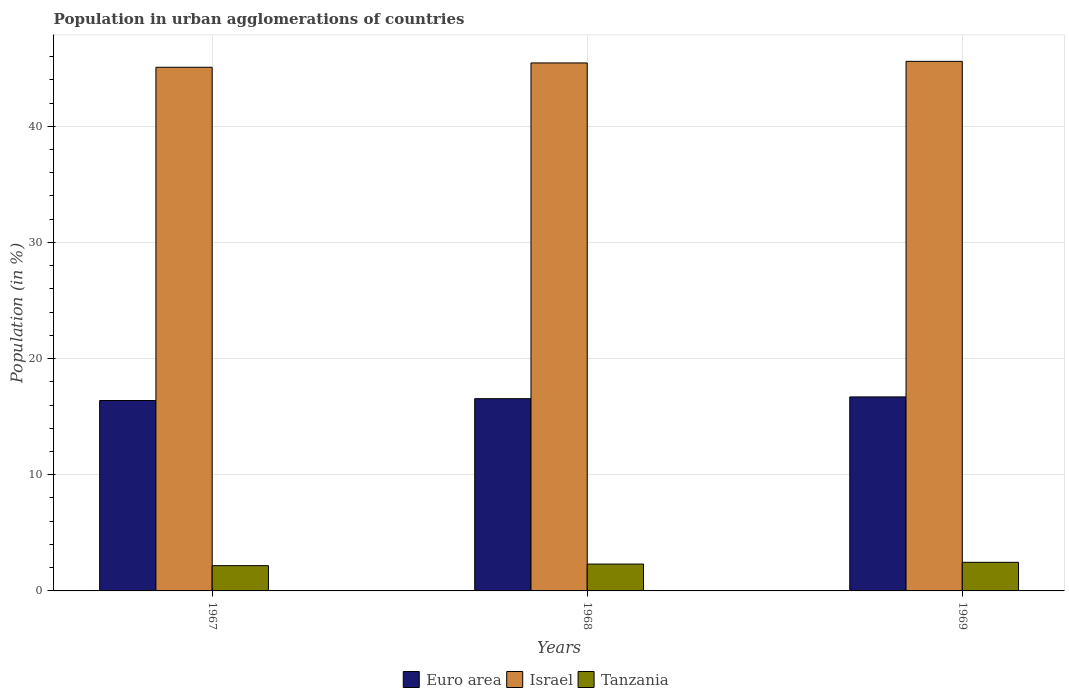Are the number of bars per tick equal to the number of legend labels?
Provide a succinct answer. Yes. Are the number of bars on each tick of the X-axis equal?
Offer a terse response. Yes. What is the label of the 1st group of bars from the left?
Your answer should be very brief. 1967. What is the percentage of population in urban agglomerations in Tanzania in 1967?
Keep it short and to the point. 2.17. Across all years, what is the maximum percentage of population in urban agglomerations in Tanzania?
Your response must be concise. 2.46. Across all years, what is the minimum percentage of population in urban agglomerations in Euro area?
Offer a very short reply. 16.39. In which year was the percentage of population in urban agglomerations in Israel maximum?
Give a very brief answer. 1969. In which year was the percentage of population in urban agglomerations in Tanzania minimum?
Provide a short and direct response. 1967. What is the total percentage of population in urban agglomerations in Israel in the graph?
Provide a succinct answer. 136.12. What is the difference between the percentage of population in urban agglomerations in Tanzania in 1967 and that in 1968?
Give a very brief answer. -0.14. What is the difference between the percentage of population in urban agglomerations in Euro area in 1969 and the percentage of population in urban agglomerations in Israel in 1967?
Your answer should be very brief. -28.38. What is the average percentage of population in urban agglomerations in Euro area per year?
Provide a succinct answer. 16.55. In the year 1969, what is the difference between the percentage of population in urban agglomerations in Euro area and percentage of population in urban agglomerations in Israel?
Make the answer very short. -28.89. What is the ratio of the percentage of population in urban agglomerations in Israel in 1967 to that in 1969?
Your answer should be very brief. 0.99. Is the percentage of population in urban agglomerations in Tanzania in 1967 less than that in 1969?
Offer a terse response. Yes. Is the difference between the percentage of population in urban agglomerations in Euro area in 1968 and 1969 greater than the difference between the percentage of population in urban agglomerations in Israel in 1968 and 1969?
Keep it short and to the point. No. What is the difference between the highest and the second highest percentage of population in urban agglomerations in Israel?
Provide a short and direct response. 0.14. What is the difference between the highest and the lowest percentage of population in urban agglomerations in Euro area?
Your answer should be very brief. 0.31. In how many years, is the percentage of population in urban agglomerations in Tanzania greater than the average percentage of population in urban agglomerations in Tanzania taken over all years?
Offer a very short reply. 1. Is the sum of the percentage of population in urban agglomerations in Euro area in 1967 and 1968 greater than the maximum percentage of population in urban agglomerations in Israel across all years?
Your response must be concise. No. What does the 1st bar from the right in 1969 represents?
Provide a short and direct response. Tanzania. What is the difference between two consecutive major ticks on the Y-axis?
Your answer should be very brief. 10. Does the graph contain any zero values?
Your response must be concise. No. How many legend labels are there?
Give a very brief answer. 3. How are the legend labels stacked?
Your answer should be compact. Horizontal. What is the title of the graph?
Ensure brevity in your answer.  Population in urban agglomerations of countries. Does "Togo" appear as one of the legend labels in the graph?
Make the answer very short. No. What is the Population (in %) of Euro area in 1967?
Make the answer very short. 16.39. What is the Population (in %) in Israel in 1967?
Keep it short and to the point. 45.08. What is the Population (in %) in Tanzania in 1967?
Provide a succinct answer. 2.17. What is the Population (in %) of Euro area in 1968?
Your response must be concise. 16.55. What is the Population (in %) in Israel in 1968?
Give a very brief answer. 45.45. What is the Population (in %) in Tanzania in 1968?
Keep it short and to the point. 2.31. What is the Population (in %) in Euro area in 1969?
Give a very brief answer. 16.7. What is the Population (in %) of Israel in 1969?
Offer a terse response. 45.59. What is the Population (in %) in Tanzania in 1969?
Offer a terse response. 2.46. Across all years, what is the maximum Population (in %) of Euro area?
Give a very brief answer. 16.7. Across all years, what is the maximum Population (in %) in Israel?
Offer a very short reply. 45.59. Across all years, what is the maximum Population (in %) in Tanzania?
Make the answer very short. 2.46. Across all years, what is the minimum Population (in %) in Euro area?
Your response must be concise. 16.39. Across all years, what is the minimum Population (in %) in Israel?
Provide a short and direct response. 45.08. Across all years, what is the minimum Population (in %) in Tanzania?
Provide a succinct answer. 2.17. What is the total Population (in %) in Euro area in the graph?
Your answer should be compact. 49.64. What is the total Population (in %) of Israel in the graph?
Make the answer very short. 136.12. What is the total Population (in %) in Tanzania in the graph?
Offer a very short reply. 6.95. What is the difference between the Population (in %) of Euro area in 1967 and that in 1968?
Provide a short and direct response. -0.16. What is the difference between the Population (in %) in Israel in 1967 and that in 1968?
Make the answer very short. -0.37. What is the difference between the Population (in %) in Tanzania in 1967 and that in 1968?
Offer a terse response. -0.14. What is the difference between the Population (in %) in Euro area in 1967 and that in 1969?
Your response must be concise. -0.31. What is the difference between the Population (in %) in Israel in 1967 and that in 1969?
Keep it short and to the point. -0.51. What is the difference between the Population (in %) of Tanzania in 1967 and that in 1969?
Your response must be concise. -0.29. What is the difference between the Population (in %) of Euro area in 1968 and that in 1969?
Ensure brevity in your answer.  -0.15. What is the difference between the Population (in %) of Israel in 1968 and that in 1969?
Keep it short and to the point. -0.14. What is the difference between the Population (in %) of Tanzania in 1968 and that in 1969?
Keep it short and to the point. -0.15. What is the difference between the Population (in %) in Euro area in 1967 and the Population (in %) in Israel in 1968?
Keep it short and to the point. -29.06. What is the difference between the Population (in %) in Euro area in 1967 and the Population (in %) in Tanzania in 1968?
Offer a very short reply. 14.08. What is the difference between the Population (in %) in Israel in 1967 and the Population (in %) in Tanzania in 1968?
Make the answer very short. 42.77. What is the difference between the Population (in %) in Euro area in 1967 and the Population (in %) in Israel in 1969?
Your response must be concise. -29.2. What is the difference between the Population (in %) in Euro area in 1967 and the Population (in %) in Tanzania in 1969?
Your response must be concise. 13.93. What is the difference between the Population (in %) in Israel in 1967 and the Population (in %) in Tanzania in 1969?
Your response must be concise. 42.62. What is the difference between the Population (in %) in Euro area in 1968 and the Population (in %) in Israel in 1969?
Ensure brevity in your answer.  -29.04. What is the difference between the Population (in %) of Euro area in 1968 and the Population (in %) of Tanzania in 1969?
Your answer should be very brief. 14.09. What is the difference between the Population (in %) in Israel in 1968 and the Population (in %) in Tanzania in 1969?
Your answer should be very brief. 42.99. What is the average Population (in %) in Euro area per year?
Ensure brevity in your answer.  16.55. What is the average Population (in %) in Israel per year?
Make the answer very short. 45.37. What is the average Population (in %) in Tanzania per year?
Your response must be concise. 2.32. In the year 1967, what is the difference between the Population (in %) of Euro area and Population (in %) of Israel?
Give a very brief answer. -28.69. In the year 1967, what is the difference between the Population (in %) in Euro area and Population (in %) in Tanzania?
Make the answer very short. 14.22. In the year 1967, what is the difference between the Population (in %) of Israel and Population (in %) of Tanzania?
Provide a succinct answer. 42.91. In the year 1968, what is the difference between the Population (in %) in Euro area and Population (in %) in Israel?
Give a very brief answer. -28.9. In the year 1968, what is the difference between the Population (in %) in Euro area and Population (in %) in Tanzania?
Make the answer very short. 14.24. In the year 1968, what is the difference between the Population (in %) of Israel and Population (in %) of Tanzania?
Your answer should be very brief. 43.14. In the year 1969, what is the difference between the Population (in %) in Euro area and Population (in %) in Israel?
Offer a very short reply. -28.89. In the year 1969, what is the difference between the Population (in %) of Euro area and Population (in %) of Tanzania?
Make the answer very short. 14.24. In the year 1969, what is the difference between the Population (in %) in Israel and Population (in %) in Tanzania?
Keep it short and to the point. 43.13. What is the ratio of the Population (in %) in Euro area in 1967 to that in 1968?
Your answer should be compact. 0.99. What is the ratio of the Population (in %) in Israel in 1967 to that in 1968?
Give a very brief answer. 0.99. What is the ratio of the Population (in %) of Tanzania in 1967 to that in 1968?
Ensure brevity in your answer.  0.94. What is the ratio of the Population (in %) of Euro area in 1967 to that in 1969?
Ensure brevity in your answer.  0.98. What is the ratio of the Population (in %) in Israel in 1967 to that in 1969?
Make the answer very short. 0.99. What is the ratio of the Population (in %) of Tanzania in 1967 to that in 1969?
Offer a terse response. 0.88. What is the ratio of the Population (in %) in Euro area in 1968 to that in 1969?
Give a very brief answer. 0.99. What is the ratio of the Population (in %) of Tanzania in 1968 to that in 1969?
Offer a very short reply. 0.94. What is the difference between the highest and the second highest Population (in %) in Euro area?
Your answer should be very brief. 0.15. What is the difference between the highest and the second highest Population (in %) in Israel?
Provide a succinct answer. 0.14. What is the difference between the highest and the second highest Population (in %) in Tanzania?
Provide a short and direct response. 0.15. What is the difference between the highest and the lowest Population (in %) in Euro area?
Your answer should be compact. 0.31. What is the difference between the highest and the lowest Population (in %) of Israel?
Keep it short and to the point. 0.51. What is the difference between the highest and the lowest Population (in %) in Tanzania?
Offer a terse response. 0.29. 